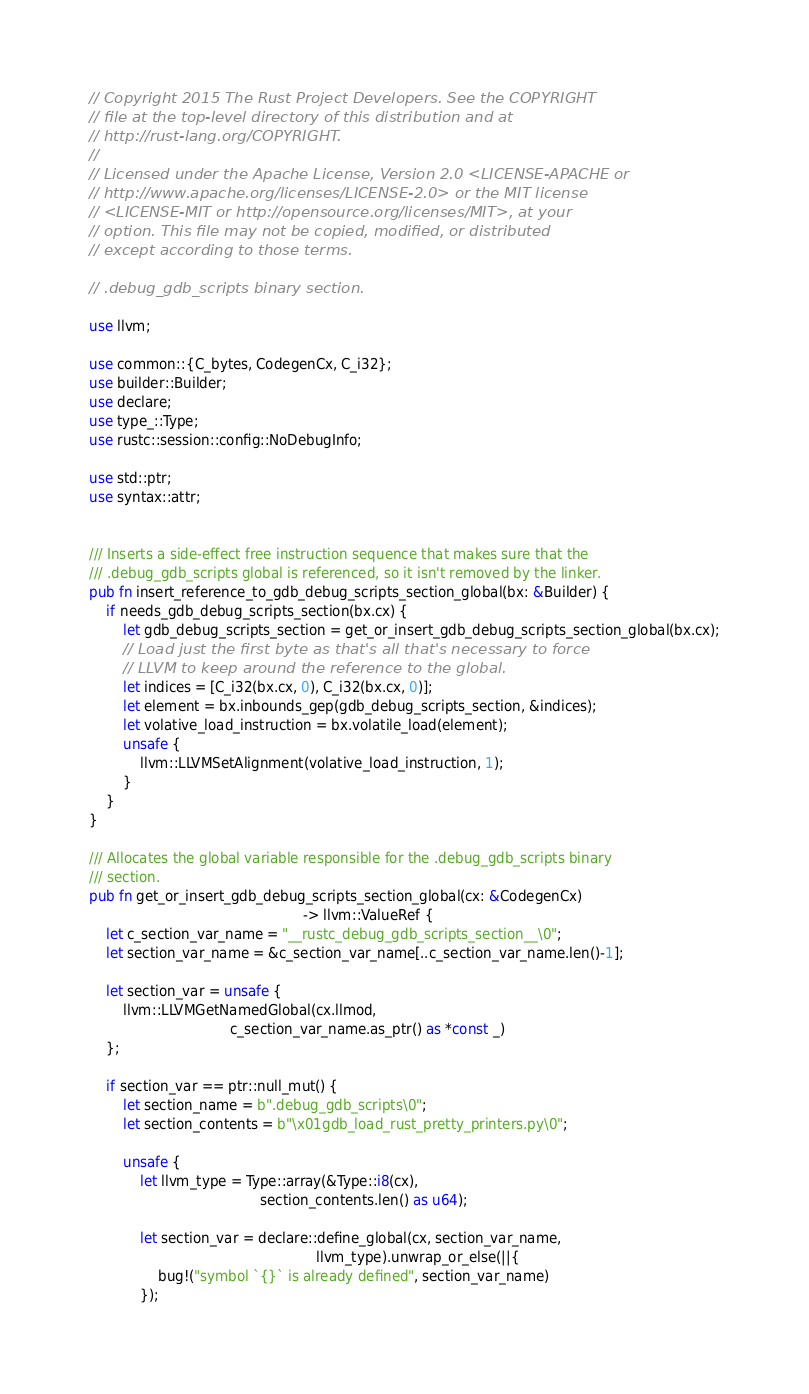Convert code to text. <code><loc_0><loc_0><loc_500><loc_500><_Rust_>// Copyright 2015 The Rust Project Developers. See the COPYRIGHT
// file at the top-level directory of this distribution and at
// http://rust-lang.org/COPYRIGHT.
//
// Licensed under the Apache License, Version 2.0 <LICENSE-APACHE or
// http://www.apache.org/licenses/LICENSE-2.0> or the MIT license
// <LICENSE-MIT or http://opensource.org/licenses/MIT>, at your
// option. This file may not be copied, modified, or distributed
// except according to those terms.

// .debug_gdb_scripts binary section.

use llvm;

use common::{C_bytes, CodegenCx, C_i32};
use builder::Builder;
use declare;
use type_::Type;
use rustc::session::config::NoDebugInfo;

use std::ptr;
use syntax::attr;


/// Inserts a side-effect free instruction sequence that makes sure that the
/// .debug_gdb_scripts global is referenced, so it isn't removed by the linker.
pub fn insert_reference_to_gdb_debug_scripts_section_global(bx: &Builder) {
    if needs_gdb_debug_scripts_section(bx.cx) {
        let gdb_debug_scripts_section = get_or_insert_gdb_debug_scripts_section_global(bx.cx);
        // Load just the first byte as that's all that's necessary to force
        // LLVM to keep around the reference to the global.
        let indices = [C_i32(bx.cx, 0), C_i32(bx.cx, 0)];
        let element = bx.inbounds_gep(gdb_debug_scripts_section, &indices);
        let volative_load_instruction = bx.volatile_load(element);
        unsafe {
            llvm::LLVMSetAlignment(volative_load_instruction, 1);
        }
    }
}

/// Allocates the global variable responsible for the .debug_gdb_scripts binary
/// section.
pub fn get_or_insert_gdb_debug_scripts_section_global(cx: &CodegenCx)
                                                  -> llvm::ValueRef {
    let c_section_var_name = "__rustc_debug_gdb_scripts_section__\0";
    let section_var_name = &c_section_var_name[..c_section_var_name.len()-1];

    let section_var = unsafe {
        llvm::LLVMGetNamedGlobal(cx.llmod,
                                 c_section_var_name.as_ptr() as *const _)
    };

    if section_var == ptr::null_mut() {
        let section_name = b".debug_gdb_scripts\0";
        let section_contents = b"\x01gdb_load_rust_pretty_printers.py\0";

        unsafe {
            let llvm_type = Type::array(&Type::i8(cx),
                                        section_contents.len() as u64);

            let section_var = declare::define_global(cx, section_var_name,
                                                     llvm_type).unwrap_or_else(||{
                bug!("symbol `{}` is already defined", section_var_name)
            });</code> 